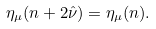<formula> <loc_0><loc_0><loc_500><loc_500>\eta _ { \mu } ( n + 2 \hat { \nu } ) = \eta _ { \mu } ( n ) .</formula> 